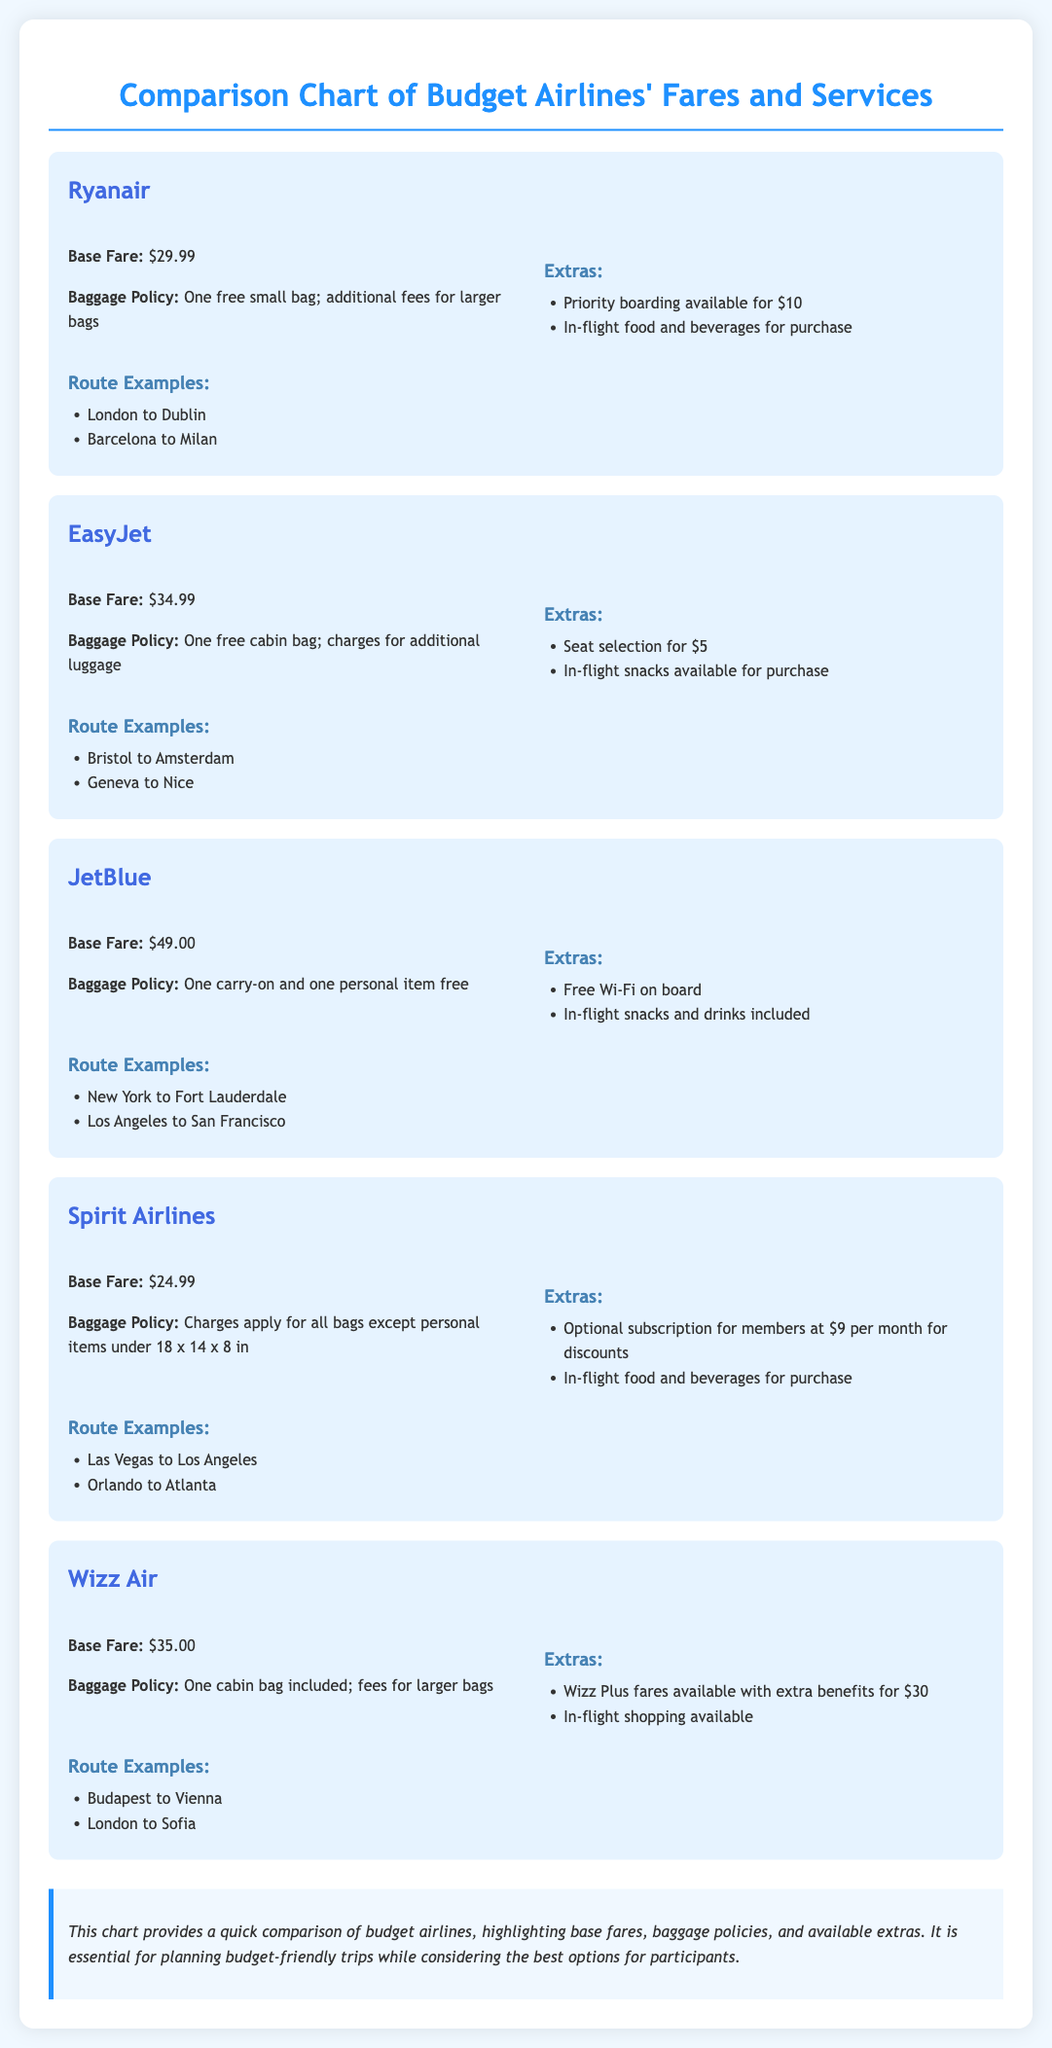What is the base fare for Ryanair? The base fare for Ryanair is $29.99.
Answer: $29.99 Which airline has the lowest base fare? Spirit Airlines has the lowest base fare of $24.99.
Answer: $24.99 What is included in JetBlue's baggage policy? JetBlue’s baggage policy includes one carry-on and one personal item free.
Answer: One carry-on and one personal item free How much does priority boarding cost with Ryanair? Priority boarding with Ryanair costs $10.
Answer: $10 What is an extra benefit offered by Wizz Air for $30? Wizz Air offers Wizz Plus fares with extra benefits for $30.
Answer: Wizz Plus fares for $30 How many routes are provided as examples for EasyJet? There are two route examples provided for EasyJet.
Answer: Two What type of items are free to carry on with EasyJet? One free cabin bag is allowed with EasyJet.
Answer: One free cabin bag Which airline offers free Wi-Fi on board? JetBlue offers free Wi-Fi on board.
Answer: JetBlue What is the baggage policy of Spirit Airlines? Spirit Airlines charges apply for all bags except personal items under 18 x 14 x 8 in.
Answer: Charges apply for all bags except personal items under 18 x 14 x 8 in 